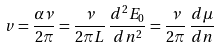<formula> <loc_0><loc_0><loc_500><loc_500>v = \frac { \alpha \nu } { 2 \pi } = \frac { \nu } { 2 \pi L } \, \frac { d ^ { 2 } E _ { 0 } } { d n ^ { 2 } } = \frac { \nu } { 2 \pi } \, \frac { d \mu } { d n }</formula> 